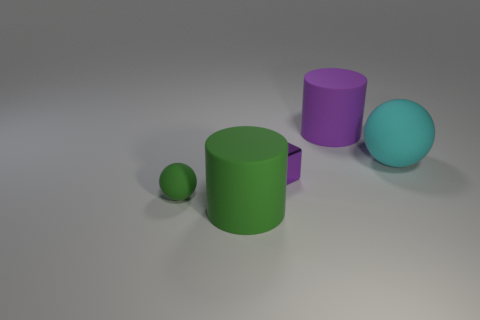Does the metallic block have the same color as the rubber ball to the right of the small green rubber sphere?
Your answer should be compact. No. What is the shape of the purple object that is right of the metallic thing?
Provide a short and direct response. Cylinder. What number of other things are there of the same material as the tiny green sphere
Your answer should be very brief. 3. What is the material of the green cylinder?
Offer a very short reply. Rubber. How many big objects are cubes or cyan metal spheres?
Provide a short and direct response. 0. How many large things are behind the tiny purple metallic thing?
Make the answer very short. 2. Are there any other metal blocks that have the same color as the small cube?
Offer a very short reply. No. What shape is the cyan rubber object that is the same size as the purple rubber thing?
Make the answer very short. Sphere. What number of yellow things are big rubber cylinders or tiny spheres?
Ensure brevity in your answer.  0. How many other matte balls have the same size as the green sphere?
Make the answer very short. 0. 